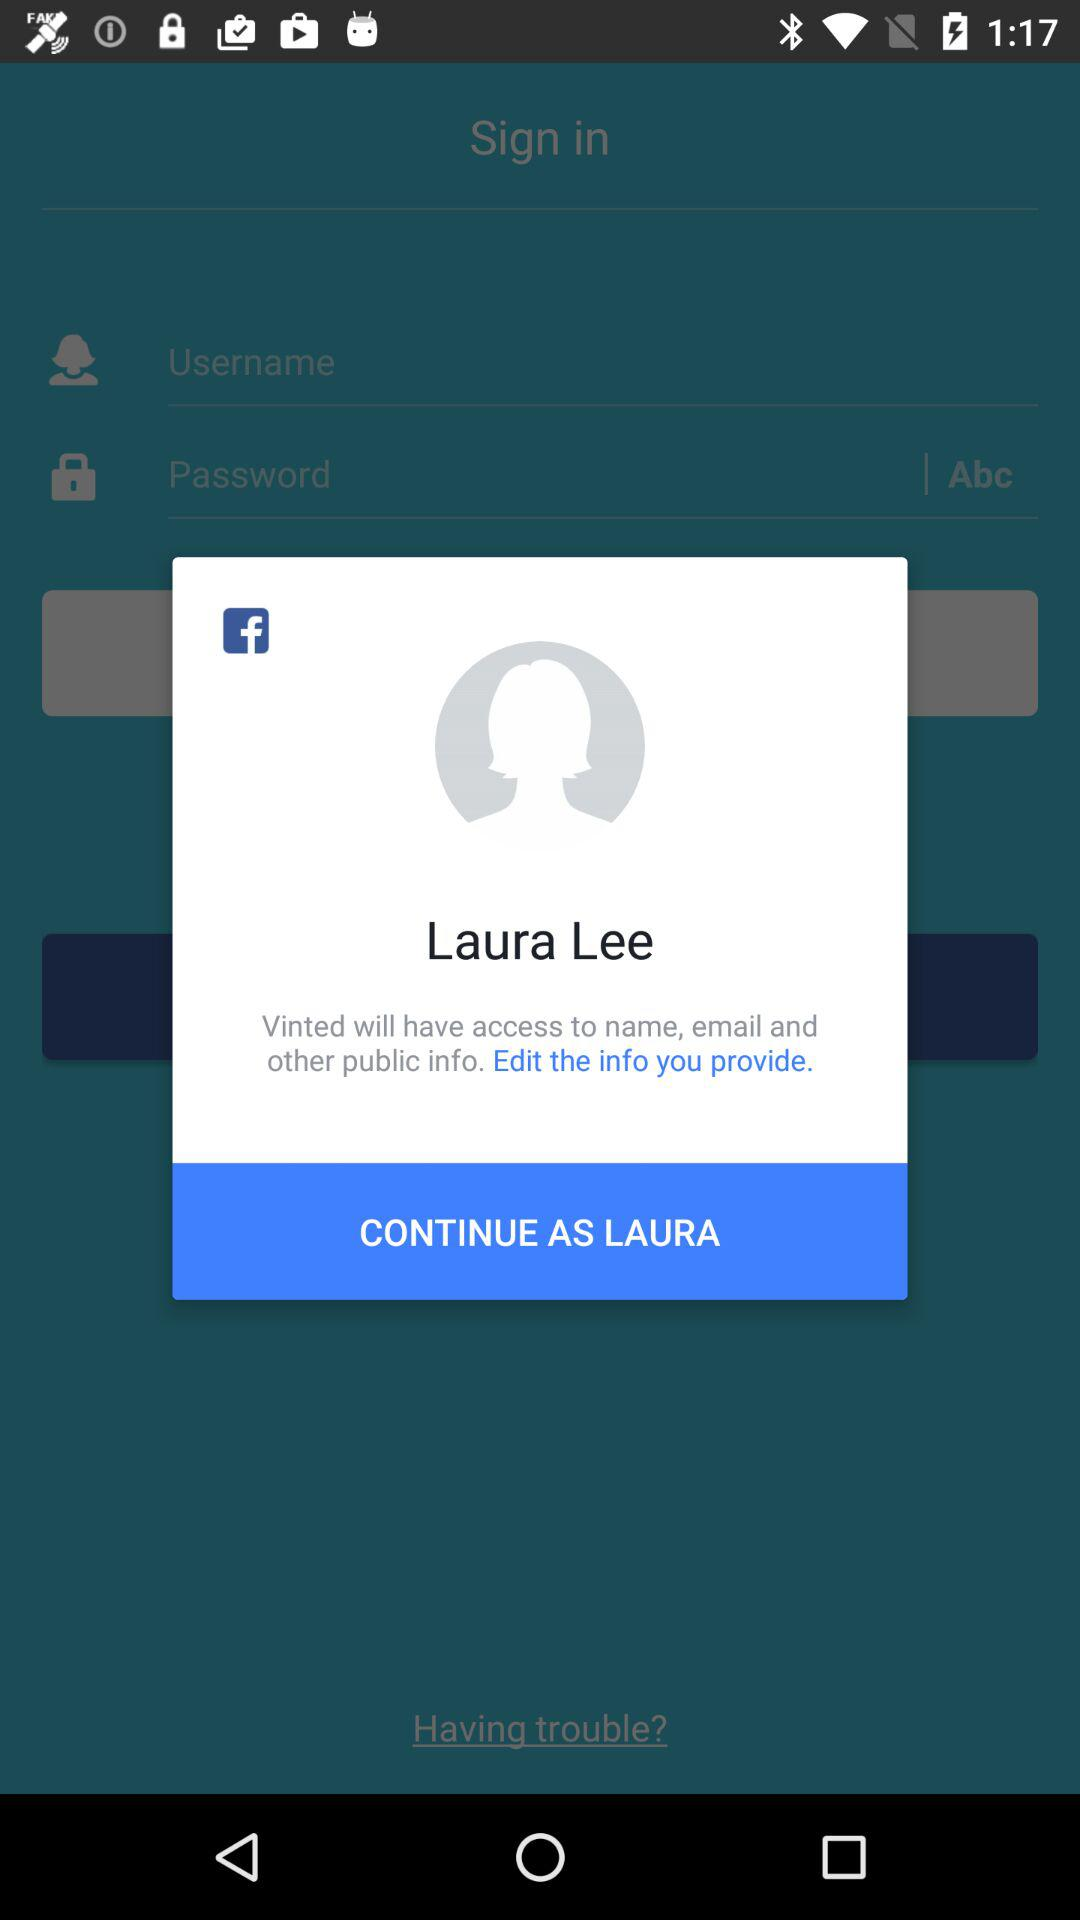How many actions are available to the user?
Answer the question using a single word or phrase. 2 